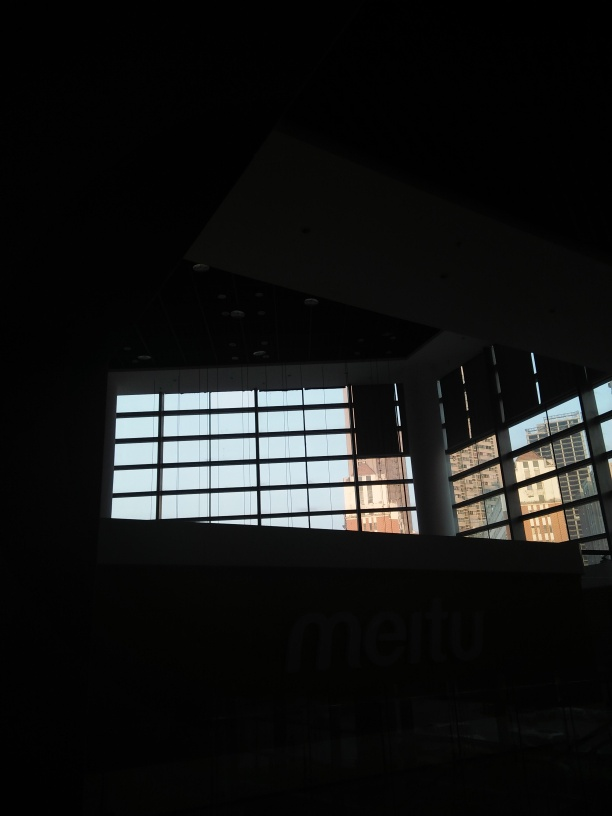Are there any quality issues with this image? Yes, the image suffers from underexposure, with the majority of the details being lost in shadow. There also appears to be a lack of focus, making the image appear slightly blurry, especially noticeable in areas where some light is present. Additionally, the image is not well-composed, with the subject partially obstructed and no clear focal point. 